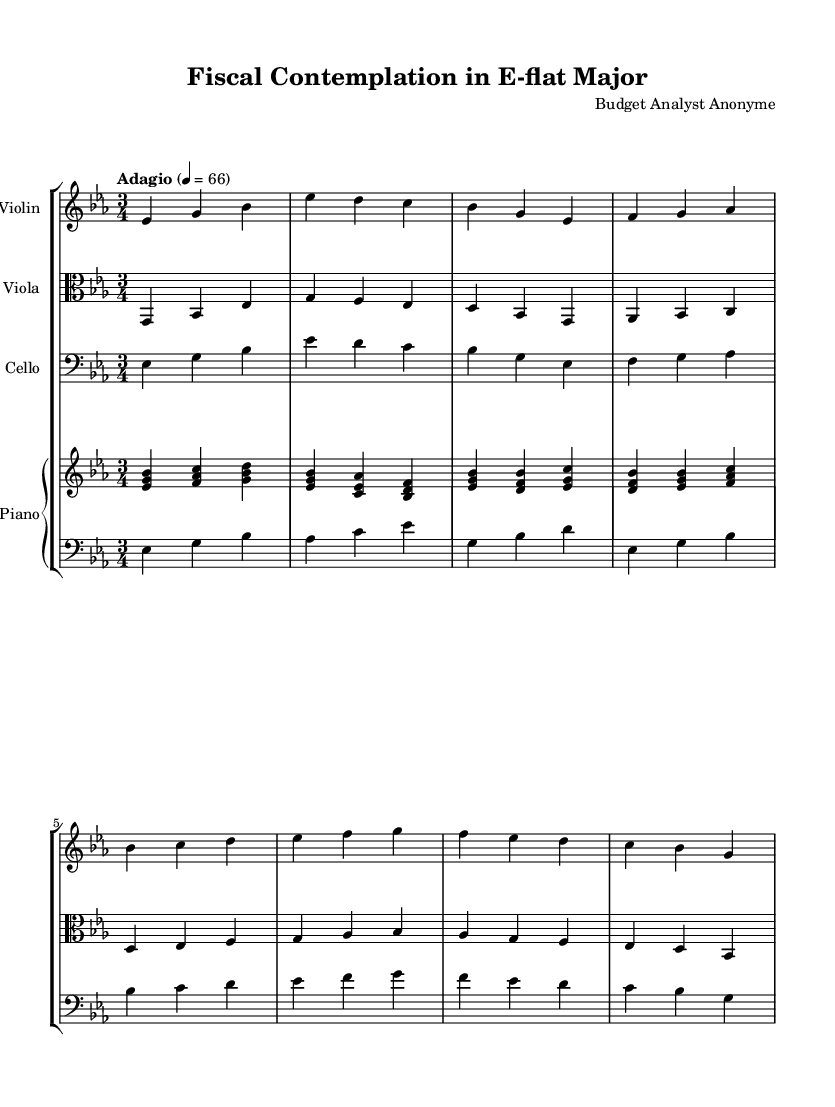What is the key signature of this music? The key signature is E-flat major, which has three flats (B♭, E♭, and A♭). This is deduced from the presence of the flat symbol indicating E-flat, visible at the beginning of the staff.
Answer: E-flat major What is the time signature of this piece? The time signature is 3/4, which indicates that there are three beats in each measure and the quarter note gets one beat. This can be observed in the notation at the beginning of the score where the numbers "3" and "4" are displayed.
Answer: 3/4 What is the tempo marking for the piece? The tempo marking is Adagio, suggesting a slow and relaxed pace. This can be found indicated at the beginning of the sheet music alongside a metronome mark of 66, providing guidance on the playing speed.
Answer: Adagio How many measures are there in the violin part? The violin part contains eight measures as counted from the initial note to the final note groupings, making sure to include each distinct time label or separation in the notation.
Answer: Eight What is the lowest note in the cello part? The lowest note in the cello part is E-flat. This is determined by locating the bottommost note in the cello staff, which is represented in the bass clef towards the beginning of its respective section.
Answer: E-flat What is the texture of the music, and how does it relate to Romantic characteristics? The texture can be described as homophonic, where the melody in the violin or piano is accompanied by harmonic support from the viola and cello. This reflects the Romantic emphasis on lyrical melodies supported by rich harmonies, often used to convey emotional depth.
Answer: Homophonic 